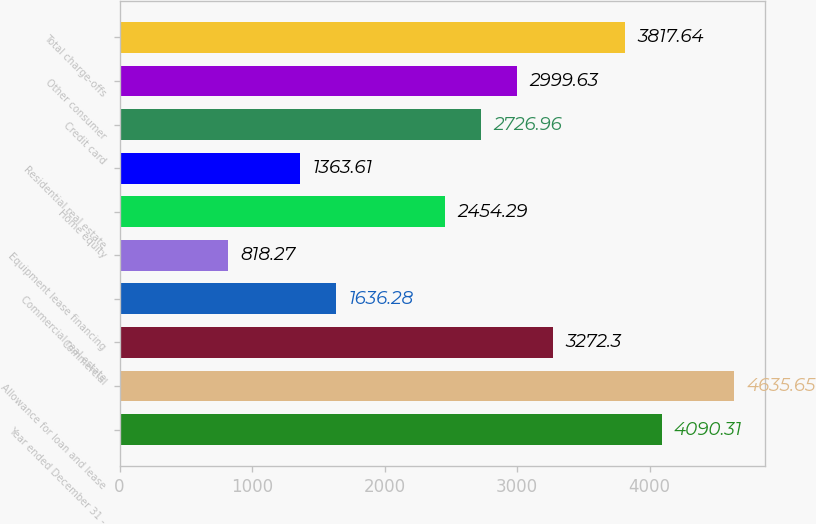<chart> <loc_0><loc_0><loc_500><loc_500><bar_chart><fcel>Year ended December 31 -<fcel>Allowance for loan and lease<fcel>Commercial<fcel>Commercial real estate<fcel>Equipment lease financing<fcel>Home equity<fcel>Residential real estate<fcel>Credit card<fcel>Other consumer<fcel>Total charge-offs<nl><fcel>4090.31<fcel>4635.65<fcel>3272.3<fcel>1636.28<fcel>818.27<fcel>2454.29<fcel>1363.61<fcel>2726.96<fcel>2999.63<fcel>3817.64<nl></chart> 